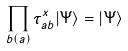Convert formula to latex. <formula><loc_0><loc_0><loc_500><loc_500>\prod _ { b ( a ) } \tau _ { a b } ^ { x } | \Psi \rangle = | \Psi \rangle</formula> 